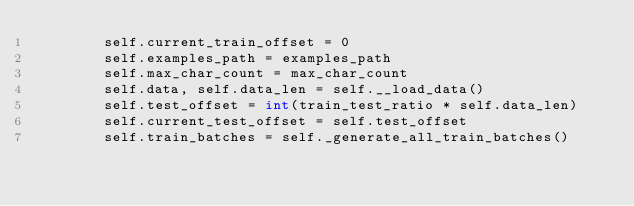<code> <loc_0><loc_0><loc_500><loc_500><_Python_>        self.current_train_offset = 0
        self.examples_path = examples_path
        self.max_char_count = max_char_count
        self.data, self.data_len = self.__load_data()
        self.test_offset = int(train_test_ratio * self.data_len)
        self.current_test_offset = self.test_offset
        self.train_batches = self._generate_all_train_batches()</code> 